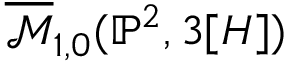Convert formula to latex. <formula><loc_0><loc_0><loc_500><loc_500>{ \overline { { \mathcal { M } } } } _ { 1 , 0 } ( \mathbb { P } ^ { 2 } , 3 [ H ] )</formula> 